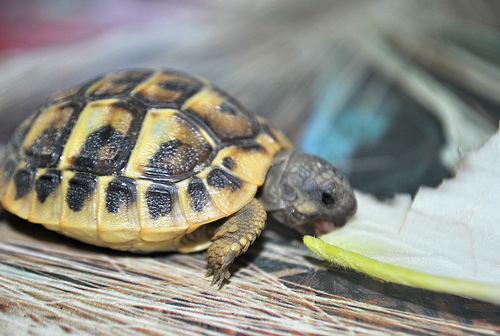<image>
Is the turtle on the table? Yes. Looking at the image, I can see the turtle is positioned on top of the table, with the table providing support. Is there a shell under the turtle? No. The shell is not positioned under the turtle. The vertical relationship between these objects is different. 